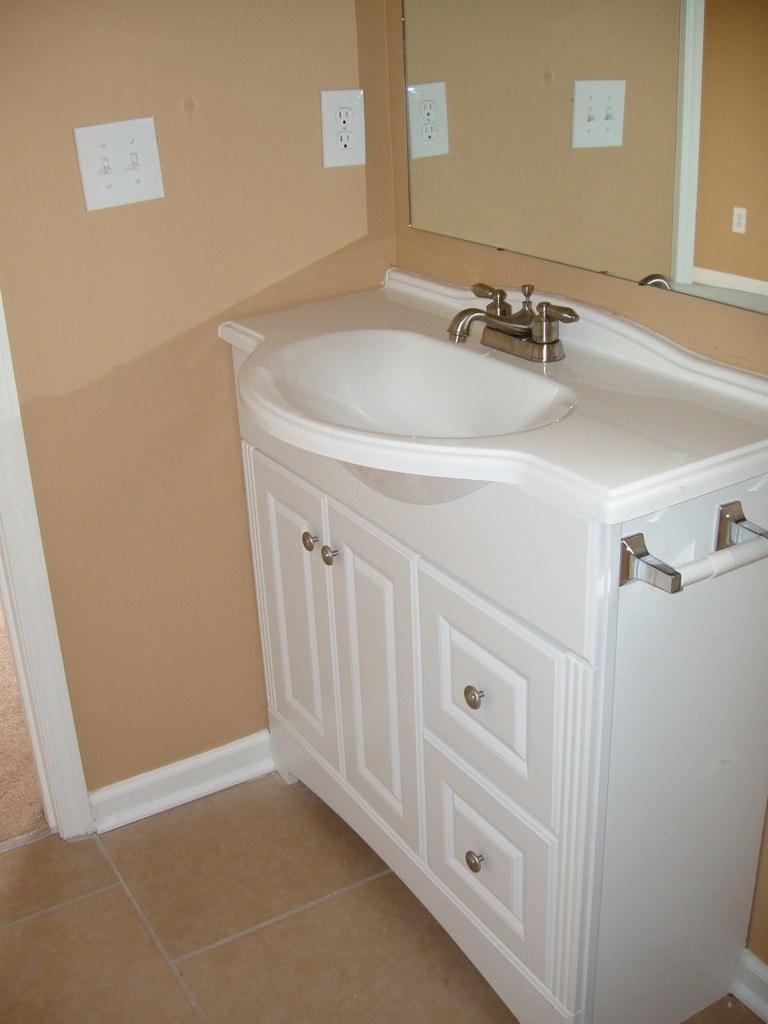Could you give a brief overview of what you see in this image? In this image I can see the white color sink and the tap. In the top there is a mirror to the brown color wall. 